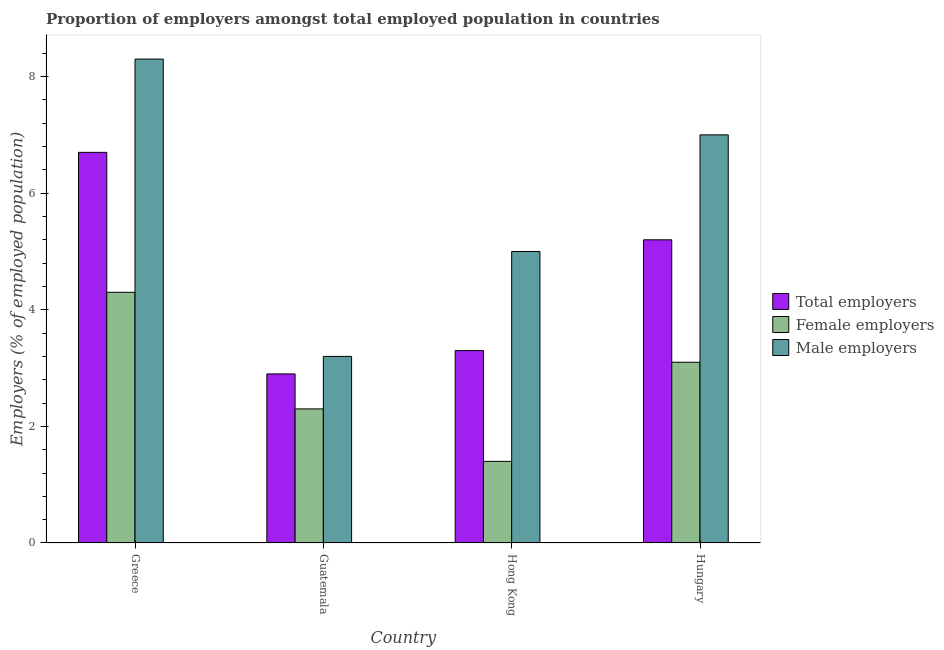How many groups of bars are there?
Your answer should be compact. 4. Are the number of bars per tick equal to the number of legend labels?
Provide a short and direct response. Yes. Are the number of bars on each tick of the X-axis equal?
Keep it short and to the point. Yes. How many bars are there on the 3rd tick from the right?
Your answer should be compact. 3. What is the label of the 2nd group of bars from the left?
Provide a succinct answer. Guatemala. In how many cases, is the number of bars for a given country not equal to the number of legend labels?
Make the answer very short. 0. What is the percentage of total employers in Greece?
Offer a very short reply. 6.7. Across all countries, what is the maximum percentage of male employers?
Your response must be concise. 8.3. Across all countries, what is the minimum percentage of total employers?
Your response must be concise. 2.9. In which country was the percentage of female employers maximum?
Keep it short and to the point. Greece. In which country was the percentage of total employers minimum?
Your answer should be very brief. Guatemala. What is the total percentage of total employers in the graph?
Keep it short and to the point. 18.1. What is the difference between the percentage of total employers in Guatemala and that in Hong Kong?
Your answer should be compact. -0.4. What is the difference between the percentage of total employers in Hungary and the percentage of male employers in Hong Kong?
Make the answer very short. 0.2. What is the average percentage of female employers per country?
Offer a terse response. 2.78. What is the difference between the percentage of female employers and percentage of male employers in Hungary?
Your response must be concise. -3.9. In how many countries, is the percentage of male employers greater than 2.8 %?
Offer a terse response. 4. What is the ratio of the percentage of total employers in Hong Kong to that in Hungary?
Your answer should be very brief. 0.63. Is the percentage of female employers in Greece less than that in Hungary?
Your response must be concise. No. What is the difference between the highest and the second highest percentage of female employers?
Ensure brevity in your answer.  1.2. What is the difference between the highest and the lowest percentage of male employers?
Provide a succinct answer. 5.1. In how many countries, is the percentage of male employers greater than the average percentage of male employers taken over all countries?
Provide a short and direct response. 2. Is the sum of the percentage of total employers in Greece and Hungary greater than the maximum percentage of male employers across all countries?
Provide a short and direct response. Yes. What does the 1st bar from the left in Greece represents?
Your answer should be very brief. Total employers. What does the 1st bar from the right in Guatemala represents?
Offer a terse response. Male employers. Is it the case that in every country, the sum of the percentage of total employers and percentage of female employers is greater than the percentage of male employers?
Your answer should be very brief. No. What is the difference between two consecutive major ticks on the Y-axis?
Offer a very short reply. 2. Are the values on the major ticks of Y-axis written in scientific E-notation?
Your answer should be compact. No. Does the graph contain any zero values?
Provide a short and direct response. No. Does the graph contain grids?
Offer a very short reply. No. Where does the legend appear in the graph?
Your answer should be compact. Center right. How are the legend labels stacked?
Ensure brevity in your answer.  Vertical. What is the title of the graph?
Your answer should be very brief. Proportion of employers amongst total employed population in countries. What is the label or title of the X-axis?
Your answer should be very brief. Country. What is the label or title of the Y-axis?
Your answer should be compact. Employers (% of employed population). What is the Employers (% of employed population) in Total employers in Greece?
Provide a short and direct response. 6.7. What is the Employers (% of employed population) in Female employers in Greece?
Your answer should be compact. 4.3. What is the Employers (% of employed population) in Male employers in Greece?
Give a very brief answer. 8.3. What is the Employers (% of employed population) in Total employers in Guatemala?
Provide a succinct answer. 2.9. What is the Employers (% of employed population) in Female employers in Guatemala?
Your response must be concise. 2.3. What is the Employers (% of employed population) of Male employers in Guatemala?
Offer a terse response. 3.2. What is the Employers (% of employed population) in Total employers in Hong Kong?
Offer a terse response. 3.3. What is the Employers (% of employed population) of Female employers in Hong Kong?
Provide a succinct answer. 1.4. What is the Employers (% of employed population) in Total employers in Hungary?
Offer a very short reply. 5.2. What is the Employers (% of employed population) in Female employers in Hungary?
Your answer should be very brief. 3.1. Across all countries, what is the maximum Employers (% of employed population) in Total employers?
Your response must be concise. 6.7. Across all countries, what is the maximum Employers (% of employed population) in Female employers?
Your answer should be very brief. 4.3. Across all countries, what is the maximum Employers (% of employed population) in Male employers?
Provide a succinct answer. 8.3. Across all countries, what is the minimum Employers (% of employed population) of Total employers?
Keep it short and to the point. 2.9. Across all countries, what is the minimum Employers (% of employed population) in Female employers?
Keep it short and to the point. 1.4. Across all countries, what is the minimum Employers (% of employed population) in Male employers?
Ensure brevity in your answer.  3.2. What is the total Employers (% of employed population) of Male employers in the graph?
Give a very brief answer. 23.5. What is the difference between the Employers (% of employed population) of Male employers in Greece and that in Guatemala?
Offer a very short reply. 5.1. What is the difference between the Employers (% of employed population) of Male employers in Greece and that in Hungary?
Offer a terse response. 1.3. What is the difference between the Employers (% of employed population) of Male employers in Guatemala and that in Hungary?
Offer a very short reply. -3.8. What is the difference between the Employers (% of employed population) of Total employers in Greece and the Employers (% of employed population) of Female employers in Guatemala?
Your answer should be very brief. 4.4. What is the difference between the Employers (% of employed population) in Total employers in Greece and the Employers (% of employed population) in Male employers in Guatemala?
Give a very brief answer. 3.5. What is the difference between the Employers (% of employed population) in Female employers in Greece and the Employers (% of employed population) in Male employers in Guatemala?
Your response must be concise. 1.1. What is the difference between the Employers (% of employed population) in Female employers in Greece and the Employers (% of employed population) in Male employers in Hong Kong?
Offer a very short reply. -0.7. What is the difference between the Employers (% of employed population) of Total employers in Greece and the Employers (% of employed population) of Male employers in Hungary?
Provide a succinct answer. -0.3. What is the difference between the Employers (% of employed population) in Total employers in Guatemala and the Employers (% of employed population) in Male employers in Hong Kong?
Your answer should be very brief. -2.1. What is the difference between the Employers (% of employed population) of Female employers in Guatemala and the Employers (% of employed population) of Male employers in Hong Kong?
Provide a short and direct response. -2.7. What is the difference between the Employers (% of employed population) in Total employers in Guatemala and the Employers (% of employed population) in Female employers in Hungary?
Make the answer very short. -0.2. What is the difference between the Employers (% of employed population) of Total employers in Hong Kong and the Employers (% of employed population) of Male employers in Hungary?
Your response must be concise. -3.7. What is the difference between the Employers (% of employed population) of Female employers in Hong Kong and the Employers (% of employed population) of Male employers in Hungary?
Give a very brief answer. -5.6. What is the average Employers (% of employed population) of Total employers per country?
Provide a short and direct response. 4.53. What is the average Employers (% of employed population) in Female employers per country?
Keep it short and to the point. 2.77. What is the average Employers (% of employed population) in Male employers per country?
Offer a terse response. 5.88. What is the difference between the Employers (% of employed population) of Total employers and Employers (% of employed population) of Male employers in Greece?
Your answer should be very brief. -1.6. What is the difference between the Employers (% of employed population) of Female employers and Employers (% of employed population) of Male employers in Greece?
Make the answer very short. -4. What is the difference between the Employers (% of employed population) of Total employers and Employers (% of employed population) of Female employers in Guatemala?
Offer a terse response. 0.6. What is the difference between the Employers (% of employed population) of Total employers and Employers (% of employed population) of Female employers in Hungary?
Give a very brief answer. 2.1. What is the ratio of the Employers (% of employed population) in Total employers in Greece to that in Guatemala?
Your answer should be very brief. 2.31. What is the ratio of the Employers (% of employed population) in Female employers in Greece to that in Guatemala?
Your answer should be very brief. 1.87. What is the ratio of the Employers (% of employed population) of Male employers in Greece to that in Guatemala?
Offer a very short reply. 2.59. What is the ratio of the Employers (% of employed population) in Total employers in Greece to that in Hong Kong?
Offer a terse response. 2.03. What is the ratio of the Employers (% of employed population) of Female employers in Greece to that in Hong Kong?
Keep it short and to the point. 3.07. What is the ratio of the Employers (% of employed population) of Male employers in Greece to that in Hong Kong?
Your answer should be very brief. 1.66. What is the ratio of the Employers (% of employed population) in Total employers in Greece to that in Hungary?
Ensure brevity in your answer.  1.29. What is the ratio of the Employers (% of employed population) of Female employers in Greece to that in Hungary?
Your answer should be compact. 1.39. What is the ratio of the Employers (% of employed population) in Male employers in Greece to that in Hungary?
Provide a succinct answer. 1.19. What is the ratio of the Employers (% of employed population) of Total employers in Guatemala to that in Hong Kong?
Your response must be concise. 0.88. What is the ratio of the Employers (% of employed population) in Female employers in Guatemala to that in Hong Kong?
Make the answer very short. 1.64. What is the ratio of the Employers (% of employed population) of Male employers in Guatemala to that in Hong Kong?
Provide a succinct answer. 0.64. What is the ratio of the Employers (% of employed population) of Total employers in Guatemala to that in Hungary?
Provide a succinct answer. 0.56. What is the ratio of the Employers (% of employed population) in Female employers in Guatemala to that in Hungary?
Offer a very short reply. 0.74. What is the ratio of the Employers (% of employed population) of Male employers in Guatemala to that in Hungary?
Offer a terse response. 0.46. What is the ratio of the Employers (% of employed population) of Total employers in Hong Kong to that in Hungary?
Your answer should be compact. 0.63. What is the ratio of the Employers (% of employed population) in Female employers in Hong Kong to that in Hungary?
Provide a succinct answer. 0.45. What is the difference between the highest and the second highest Employers (% of employed population) of Total employers?
Your response must be concise. 1.5. 